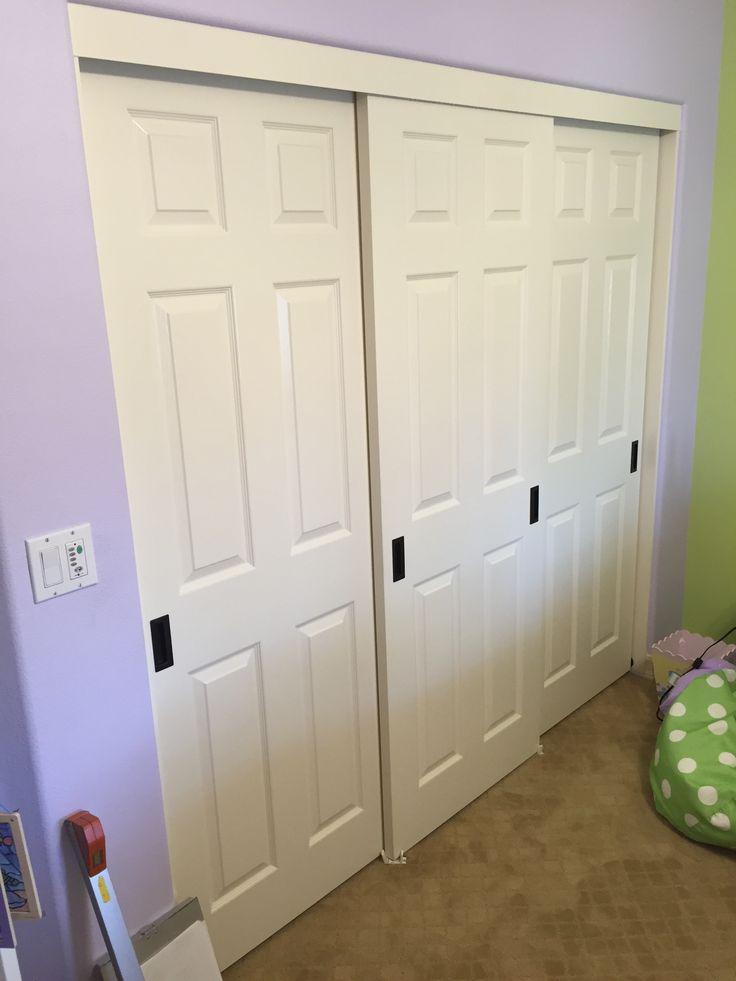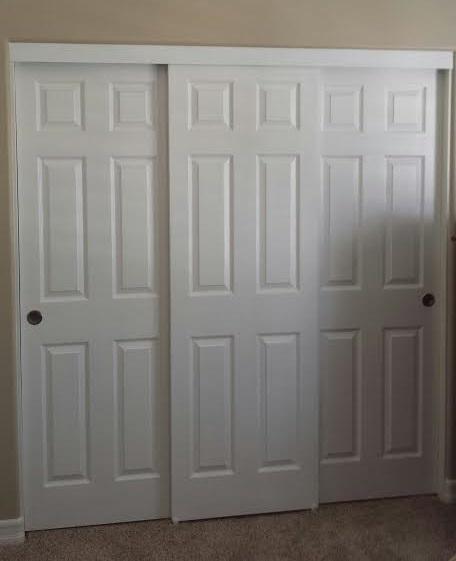The first image is the image on the left, the second image is the image on the right. Given the left and right images, does the statement "An image shows a three-section white sliding door unit with round dark handles." hold true? Answer yes or no. Yes. The first image is the image on the left, the second image is the image on the right. Analyze the images presented: Is the assertion "One three panel door has visible hardware on each door and a second three panel door has a contrasting middle band and no visible hardware." valid? Answer yes or no. No. 